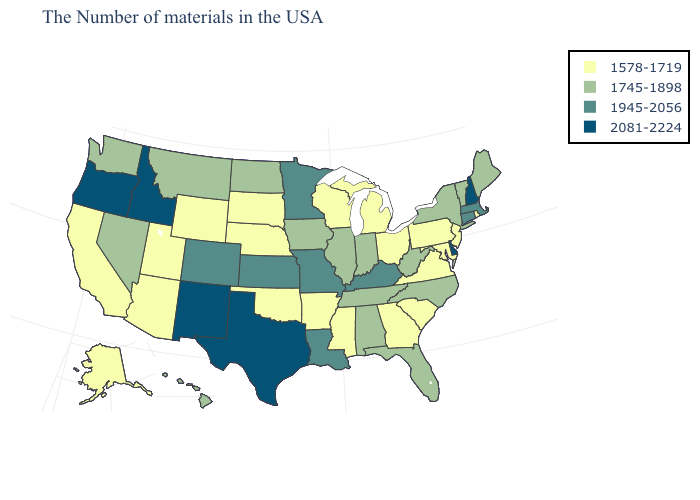What is the value of South Dakota?
Answer briefly. 1578-1719. What is the value of Mississippi?
Concise answer only. 1578-1719. What is the highest value in states that border Iowa?
Answer briefly. 1945-2056. Name the states that have a value in the range 1745-1898?
Quick response, please. Maine, Vermont, New York, North Carolina, West Virginia, Florida, Indiana, Alabama, Tennessee, Illinois, Iowa, North Dakota, Montana, Nevada, Washington, Hawaii. What is the highest value in the West ?
Answer briefly. 2081-2224. What is the highest value in the USA?
Keep it brief. 2081-2224. What is the value of West Virginia?
Write a very short answer. 1745-1898. Does the map have missing data?
Concise answer only. No. What is the highest value in the USA?
Quick response, please. 2081-2224. What is the highest value in the Northeast ?
Be succinct. 2081-2224. Does Arkansas have the lowest value in the USA?
Answer briefly. Yes. What is the lowest value in the Northeast?
Answer briefly. 1578-1719. What is the value of New Jersey?
Answer briefly. 1578-1719. What is the value of New Hampshire?
Give a very brief answer. 2081-2224. Which states hav the highest value in the West?
Concise answer only. New Mexico, Idaho, Oregon. 